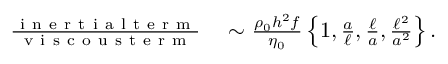Convert formula to latex. <formula><loc_0><loc_0><loc_500><loc_500>\begin{array} { r l } { \frac { i n e r t i a l t e r m } { v i s c o u s t e r m } } & \sim \frac { \rho _ { 0 } h ^ { 2 } f } { \eta _ { 0 } } \left \{ 1 , \frac { a } { \ell } , \frac { \ell } { a } , \frac { \ell ^ { 2 } } { a ^ { 2 } } \right \} . } \end{array}</formula> 